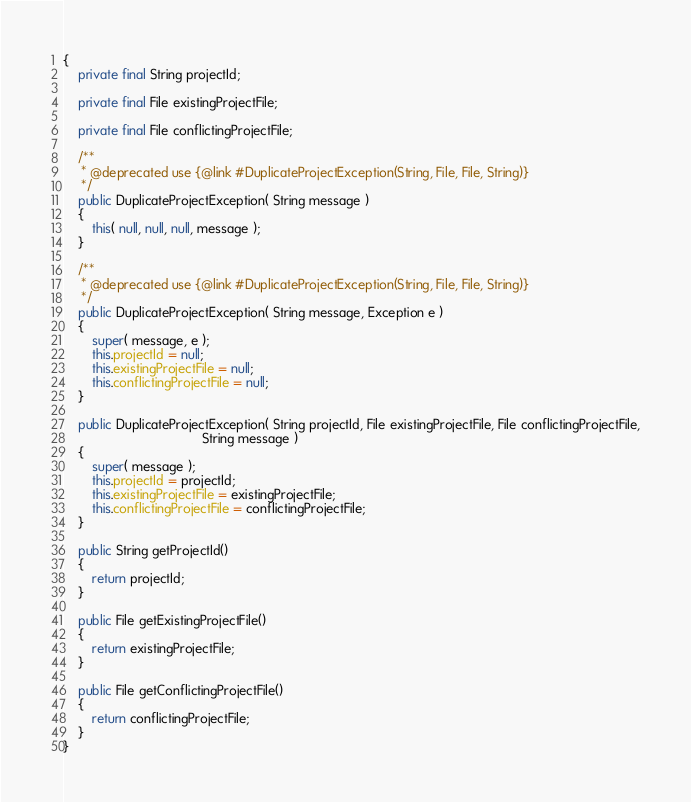Convert code to text. <code><loc_0><loc_0><loc_500><loc_500><_Java_>{
    private final String projectId;

    private final File existingProjectFile;

    private final File conflictingProjectFile;

    /**
     * @deprecated use {@link #DuplicateProjectException(String, File, File, String)}
     */
    public DuplicateProjectException( String message )
    {
        this( null, null, null, message );
    }

    /**
     * @deprecated use {@link #DuplicateProjectException(String, File, File, String)}
     */
    public DuplicateProjectException( String message, Exception e )
    {
        super( message, e );
        this.projectId = null;
        this.existingProjectFile = null;
        this.conflictingProjectFile = null;
    }

    public DuplicateProjectException( String projectId, File existingProjectFile, File conflictingProjectFile,
                                      String message )
    {
        super( message );
        this.projectId = projectId;
        this.existingProjectFile = existingProjectFile;
        this.conflictingProjectFile = conflictingProjectFile;
    }

    public String getProjectId()
    {
        return projectId;
    }

    public File getExistingProjectFile()
    {
        return existingProjectFile;
    }

    public File getConflictingProjectFile()
    {
        return conflictingProjectFile;
    }
}
</code> 